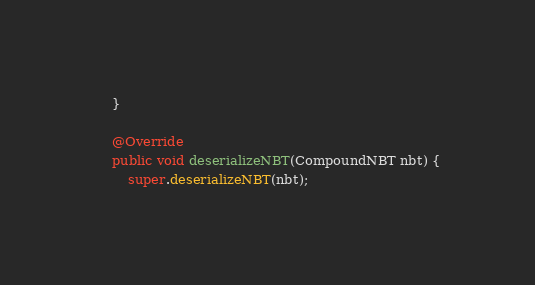<code> <loc_0><loc_0><loc_500><loc_500><_Java_>    }

    @Override
    public void deserializeNBT(CompoundNBT nbt) {
        super.deserializeNBT(nbt);</code> 